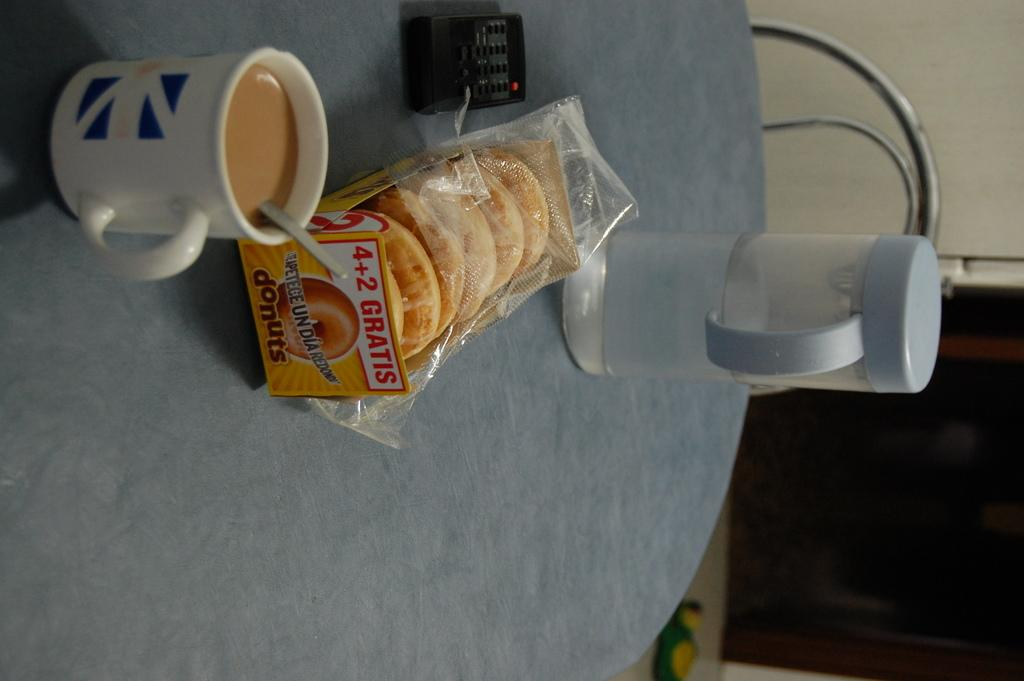<image>
Provide a brief description of the given image. back of crackers and a coffee placed on the table 